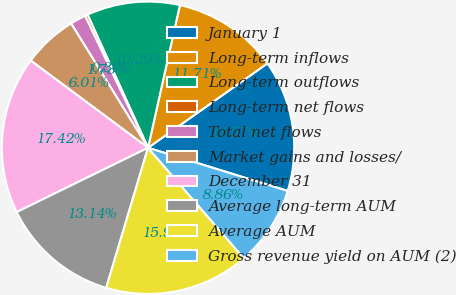Convert chart to OTSL. <chart><loc_0><loc_0><loc_500><loc_500><pie_chart><fcel>January 1<fcel>Long-term inflows<fcel>Long-term outflows<fcel>Long-term net flows<fcel>Total net flows<fcel>Market gains and losses/<fcel>December 31<fcel>Average long-term AUM<fcel>Average AUM<fcel>Gross revenue yield on AUM (2)<nl><fcel>14.57%<fcel>11.71%<fcel>10.29%<fcel>0.3%<fcel>1.73%<fcel>6.01%<fcel>17.42%<fcel>13.14%<fcel>15.99%<fcel>8.86%<nl></chart> 